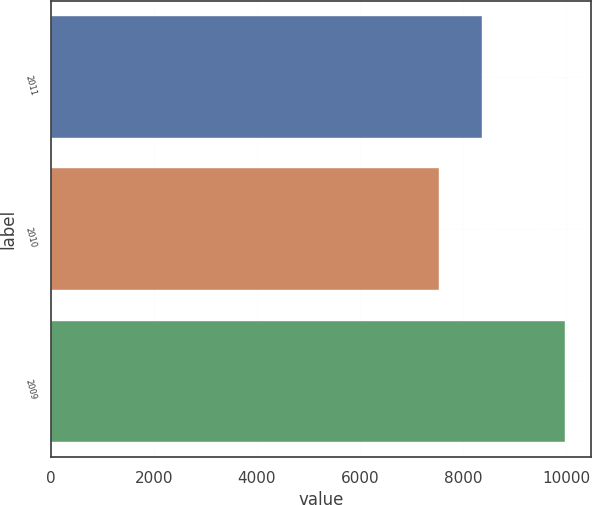<chart> <loc_0><loc_0><loc_500><loc_500><bar_chart><fcel>2011<fcel>2010<fcel>2009<nl><fcel>8368<fcel>7535<fcel>9983<nl></chart> 